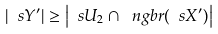Convert formula to latex. <formula><loc_0><loc_0><loc_500><loc_500>| \ s Y ^ { \prime } | \geq \left | \ s U _ { 2 } \cap \ n g b r ( \ s X ^ { \prime } ) \right |</formula> 